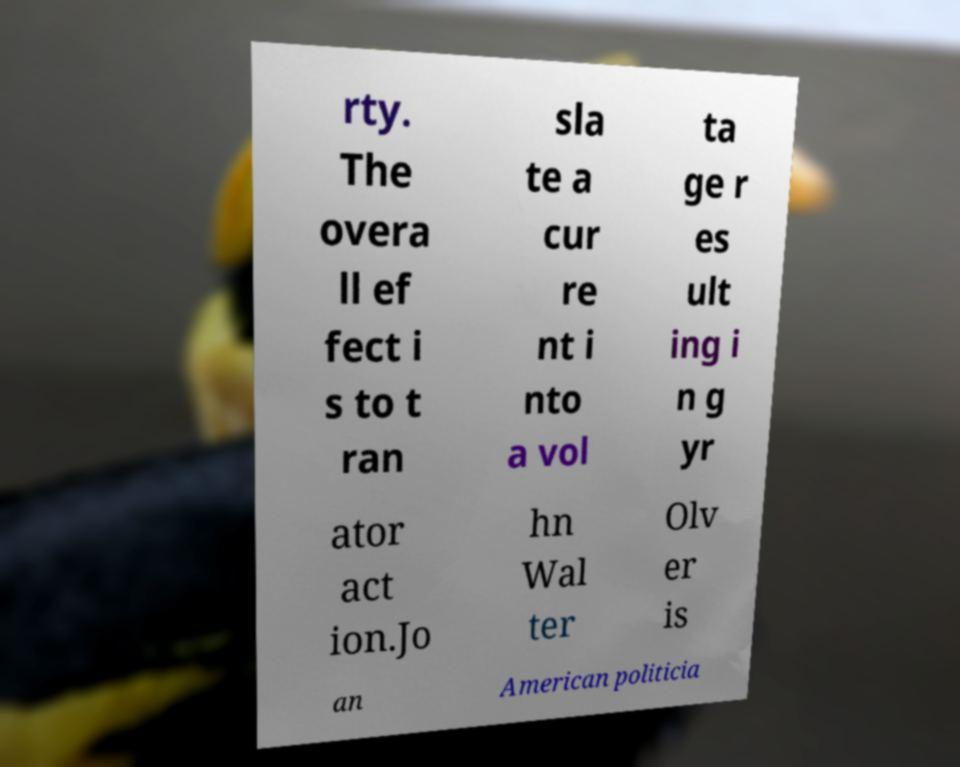Could you extract and type out the text from this image? rty. The overa ll ef fect i s to t ran sla te a cur re nt i nto a vol ta ge r es ult ing i n g yr ator act ion.Jo hn Wal ter Olv er is an American politicia 